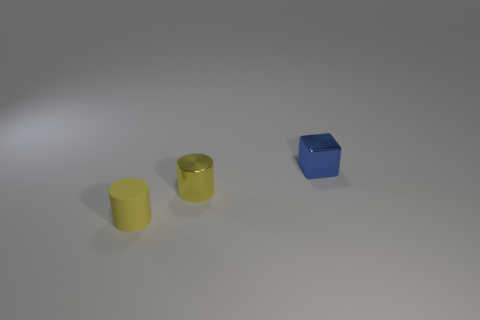There is a thing that is to the right of the yellow matte cylinder and in front of the cube; what color is it? The object to the right of the yellow matte cylinder and in front of the cube is also a cylinder and is of a similar yellow hue, although its finish seems to have more of a metallic sheen compared to the matte finish of the adjacent cylinder. 